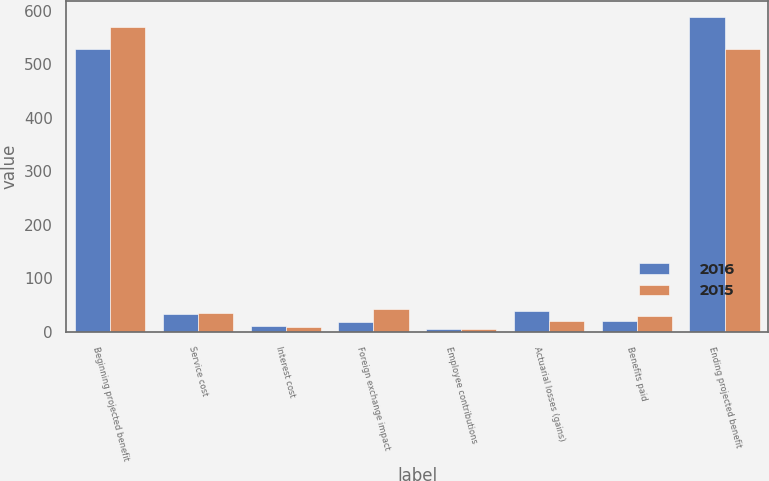Convert chart. <chart><loc_0><loc_0><loc_500><loc_500><stacked_bar_chart><ecel><fcel>Beginning projected benefit<fcel>Service cost<fcel>Interest cost<fcel>Foreign exchange impact<fcel>Employee contributions<fcel>Actuarial losses (gains)<fcel>Benefits paid<fcel>Ending projected benefit<nl><fcel>2016<fcel>529<fcel>33<fcel>11<fcel>18<fcel>6<fcel>40<fcel>20<fcel>588<nl><fcel>2015<fcel>570<fcel>36<fcel>10<fcel>43<fcel>6<fcel>21<fcel>29<fcel>529<nl></chart> 